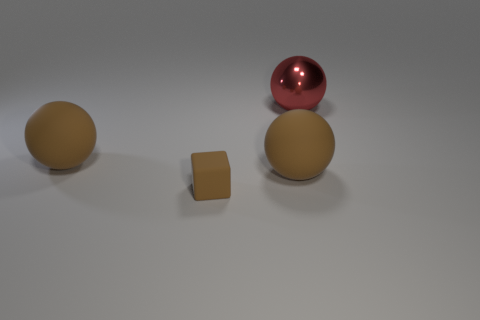Can you guess the material of these objects? Based on their appearance, the objects might be made of a plastic or ceramic material. The shiny surface of the red sphere suggests a polished finish, while the matte texture of the brown objects suggests a more porous surface. 